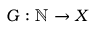<formula> <loc_0><loc_0><loc_500><loc_500>G \colon \mathbb { N } \rightarrow X</formula> 